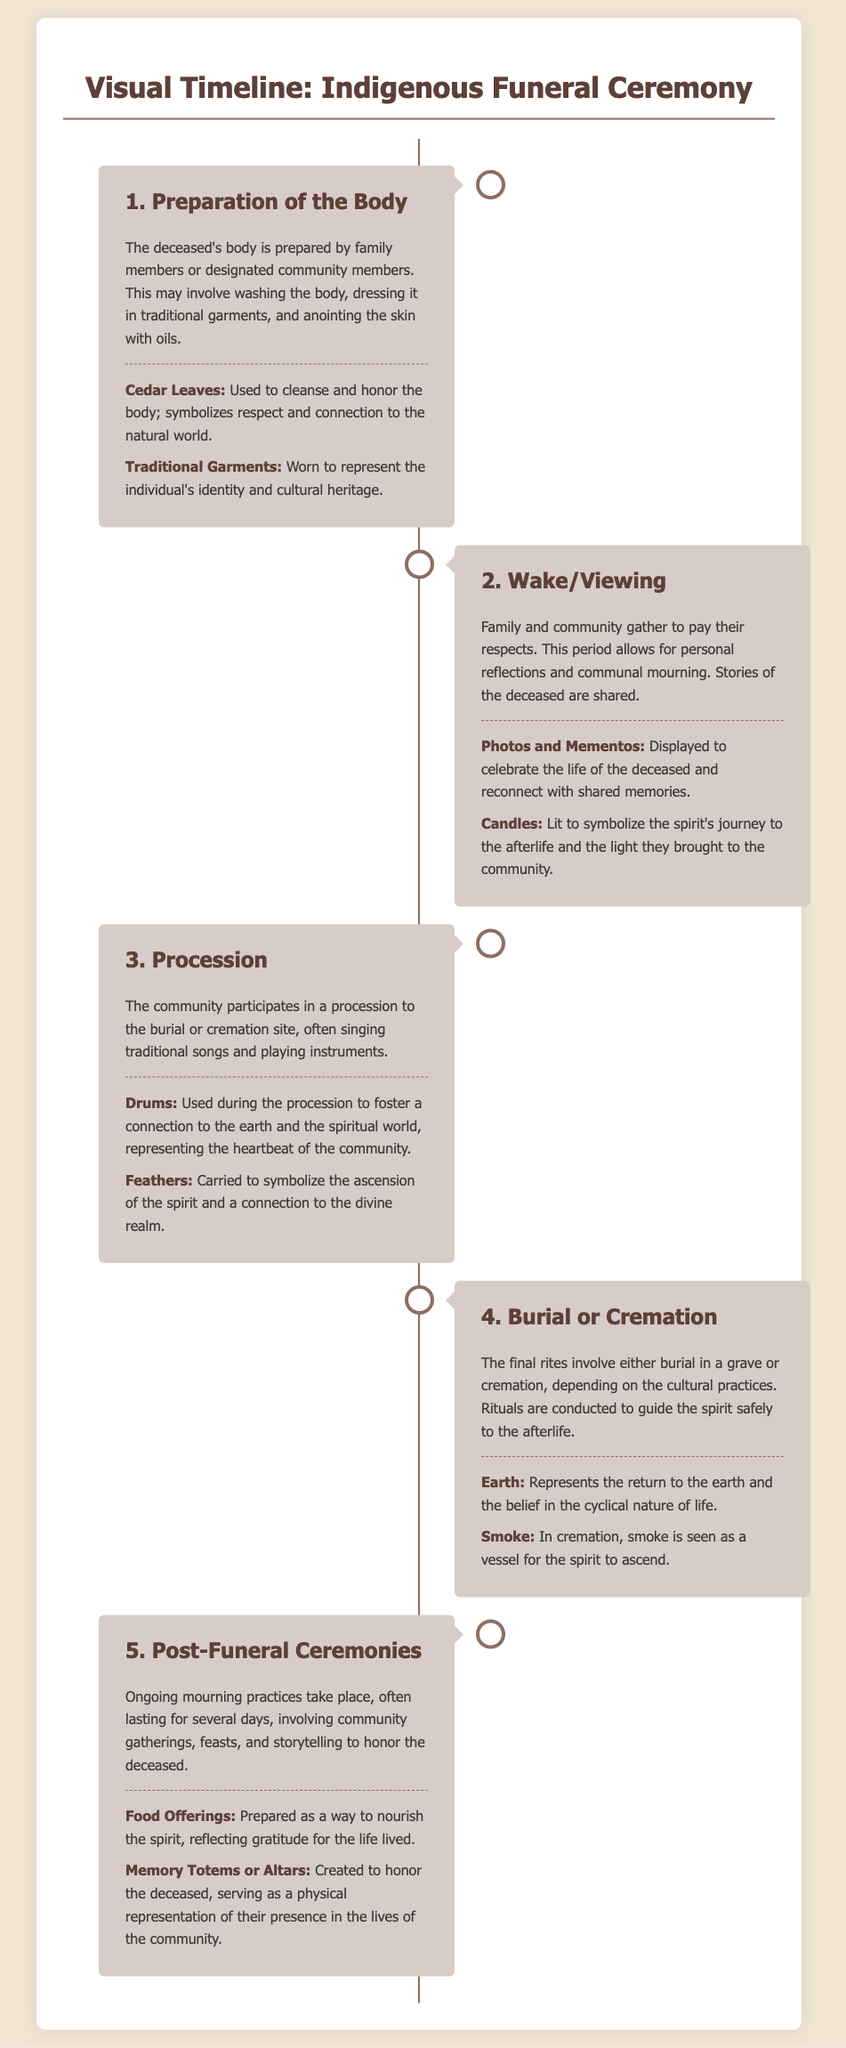What is the first stage of the traditional indigenous funeral ceremony? The document mentions the first stage as the 'Preparation of the Body', where family members prepare the deceased's body.
Answer: Preparation of the Body What cultural symbol is used to cleanse and honor the body? The document specifies 'Cedar Leaves' as a cultural symbol used for cleansing and honoring the body of the deceased.
Answer: Cedar Leaves How many stages are there in the visual timeline? The document outlines a total of five stages in the traditional indigenous funeral ceremony.
Answer: Five During the wake/viewing, what items are displayed to celebrate the life of the deceased? The document lists 'Photos and Mementos' as items displayed during the wake/viewing to celebrate the deceased's life.
Answer: Photos and Mementos What is used during the procession to represent the heartbeat of the community? According to the document, 'Drums' are used during the procession to symbolize the heartbeat of the community.
Answer: Drums What does 'Smoke' symbolize in the cremation process? The document describes 'Smoke' as a vessel for the spirit to ascend during the cremation process.
Answer: Vessel for the spirit What kind of offerings are made in post-funeral ceremonies? The document states that 'Food Offerings' are prepared as a way to nourish the spirit in post-funeral ceremonies.
Answer: Food Offerings What is the significance of 'Memory Totems or Altars'? According to the document, 'Memory Totems or Altars' serve as physical representations honoring the deceased in the lives of the community.
Answer: Physical representations honoring the deceased What is shared during the wake/viewing? The document notes that 'Stories of the deceased are shared' during the wake/viewing period.
Answer: Stories of the deceased 